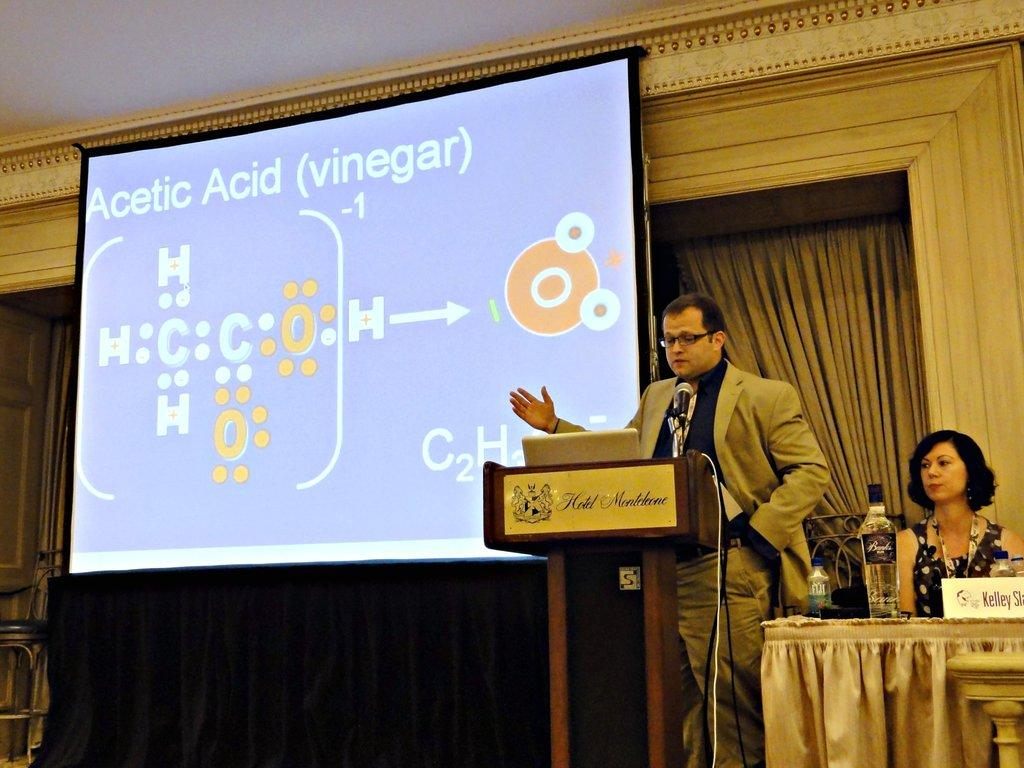What is the main object in the image? There is a screen in the image. What else can be seen in the image? There is a curtain, two people, a table, a poster, and bottles in the image. Where is the curtain located? The curtain is in the image. What is on the table? There is a poster and bottles on the table in the image. What type of punishment is being handed out by the police in the image? There are no police or punishment present in the image. What channel is the screen displaying in the image? The provided facts do not mention any specific channel being displayed on the screen. 